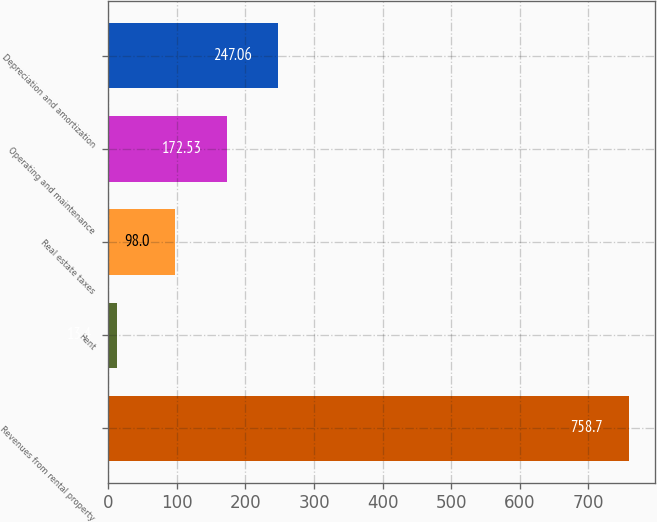<chart> <loc_0><loc_0><loc_500><loc_500><bar_chart><fcel>Revenues from rental property<fcel>Rent<fcel>Real estate taxes<fcel>Operating and maintenance<fcel>Depreciation and amortization<nl><fcel>758.7<fcel>13.4<fcel>98<fcel>172.53<fcel>247.06<nl></chart> 